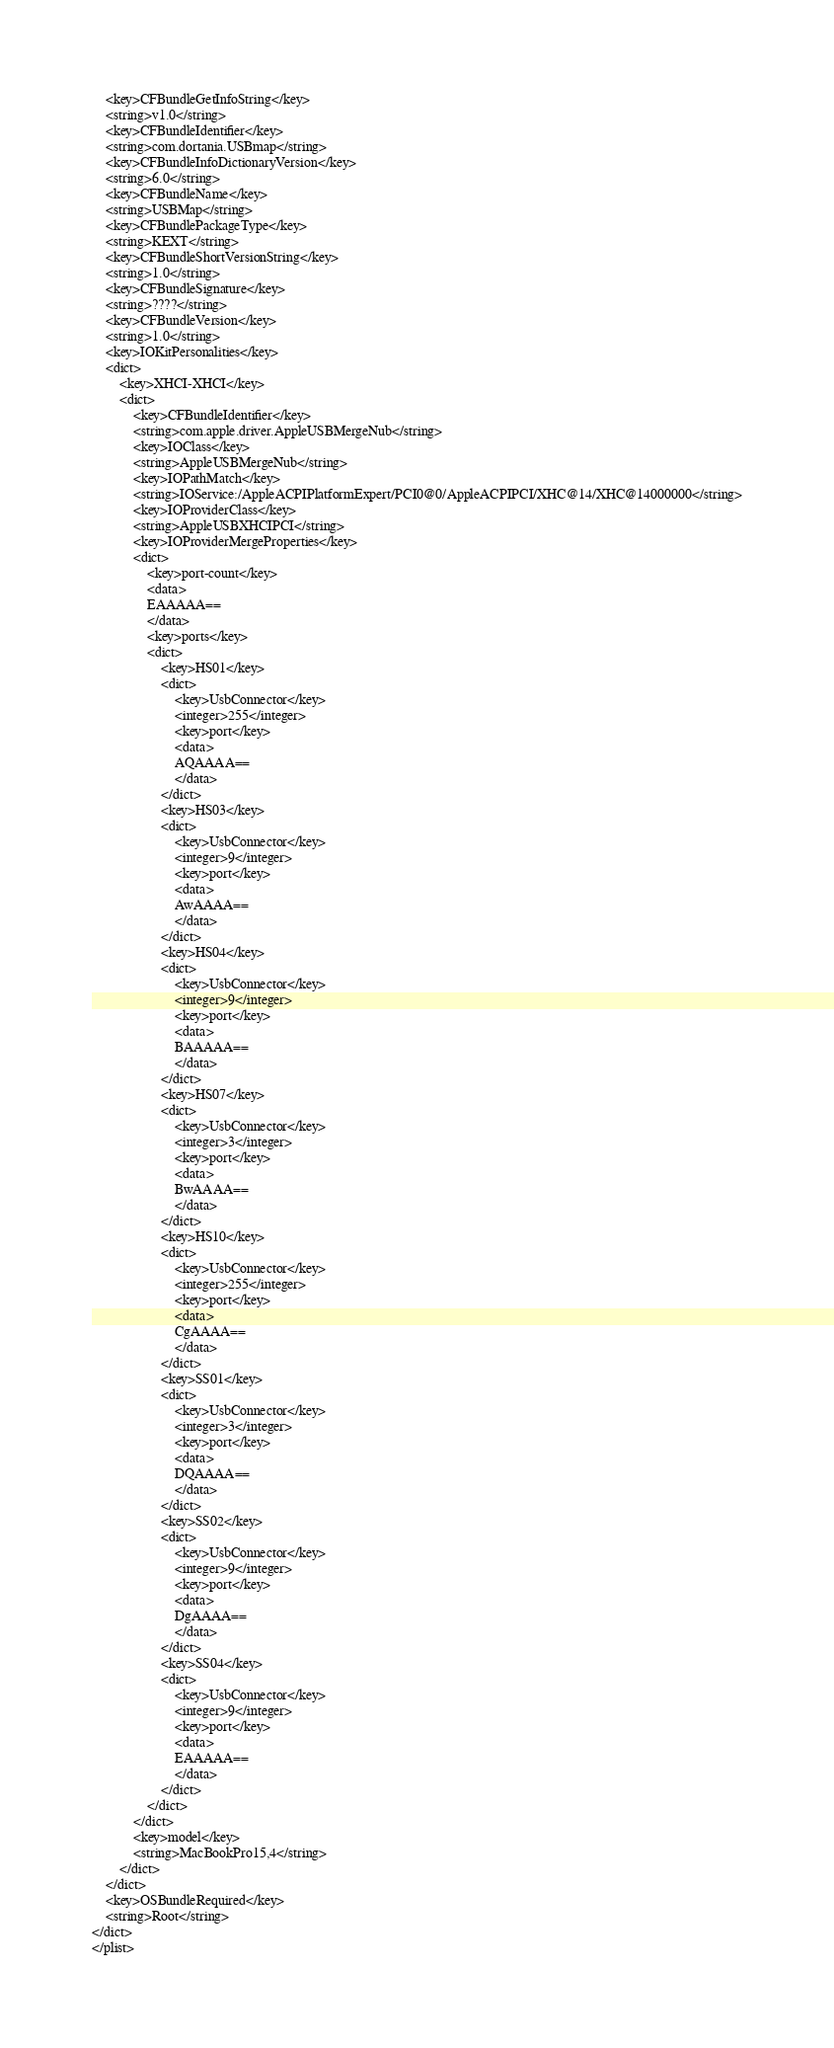<code> <loc_0><loc_0><loc_500><loc_500><_XML_>	<key>CFBundleGetInfoString</key>
	<string>v1.0</string>
	<key>CFBundleIdentifier</key>
	<string>com.dortania.USBmap</string>
	<key>CFBundleInfoDictionaryVersion</key>
	<string>6.0</string>
	<key>CFBundleName</key>
	<string>USBMap</string>
	<key>CFBundlePackageType</key>
	<string>KEXT</string>
	<key>CFBundleShortVersionString</key>
	<string>1.0</string>
	<key>CFBundleSignature</key>
	<string>????</string>
	<key>CFBundleVersion</key>
	<string>1.0</string>
	<key>IOKitPersonalities</key>
	<dict>
		<key>XHCI-XHCI</key>
		<dict>
			<key>CFBundleIdentifier</key>
			<string>com.apple.driver.AppleUSBMergeNub</string>
			<key>IOClass</key>
			<string>AppleUSBMergeNub</string>
			<key>IOPathMatch</key>
			<string>IOService:/AppleACPIPlatformExpert/PCI0@0/AppleACPIPCI/XHC@14/XHC@14000000</string>
			<key>IOProviderClass</key>
			<string>AppleUSBXHCIPCI</string>
			<key>IOProviderMergeProperties</key>
			<dict>
				<key>port-count</key>
				<data>
				EAAAAA==
				</data>
				<key>ports</key>
				<dict>
					<key>HS01</key>
					<dict>
						<key>UsbConnector</key>
						<integer>255</integer>
						<key>port</key>
						<data>
						AQAAAA==
						</data>
					</dict>
					<key>HS03</key>
					<dict>
						<key>UsbConnector</key>
						<integer>9</integer>
						<key>port</key>
						<data>
						AwAAAA==
						</data>
					</dict>
					<key>HS04</key>
					<dict>
						<key>UsbConnector</key>
						<integer>9</integer>
						<key>port</key>
						<data>
						BAAAAA==
						</data>
					</dict>
					<key>HS07</key>
					<dict>
						<key>UsbConnector</key>
						<integer>3</integer>
						<key>port</key>
						<data>
						BwAAAA==
						</data>
					</dict>
					<key>HS10</key>
					<dict>
						<key>UsbConnector</key>
						<integer>255</integer>
						<key>port</key>
						<data>
						CgAAAA==
						</data>
					</dict>
					<key>SS01</key>
					<dict>
						<key>UsbConnector</key>
						<integer>3</integer>
						<key>port</key>
						<data>
						DQAAAA==
						</data>
					</dict>
					<key>SS02</key>
					<dict>
						<key>UsbConnector</key>
						<integer>9</integer>
						<key>port</key>
						<data>
						DgAAAA==
						</data>
					</dict>
					<key>SS04</key>
					<dict>
						<key>UsbConnector</key>
						<integer>9</integer>
						<key>port</key>
						<data>
						EAAAAA==
						</data>
					</dict>
				</dict>
			</dict>
			<key>model</key>
			<string>MacBookPro15,4</string>
		</dict>
	</dict>
	<key>OSBundleRequired</key>
	<string>Root</string>
</dict>
</plist>
</code> 